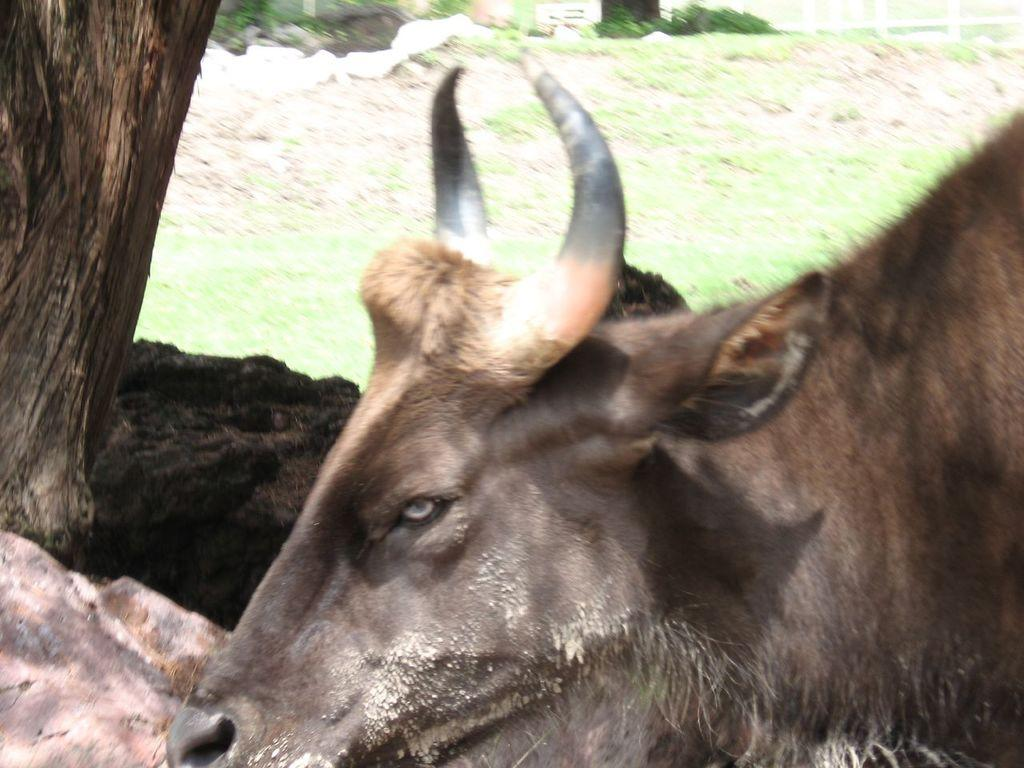What type of animal is in the image? There is a buffalo in the image. What else can be seen in the image besides the buffalo? There is a tree trunk and grass in the image. Can you describe the quality of the image? The image is slightly blurred. What type of error can be seen in the hall in the image? There is no mention of an error or a hall in the image; it features a buffalo, a tree trunk, and grass. 